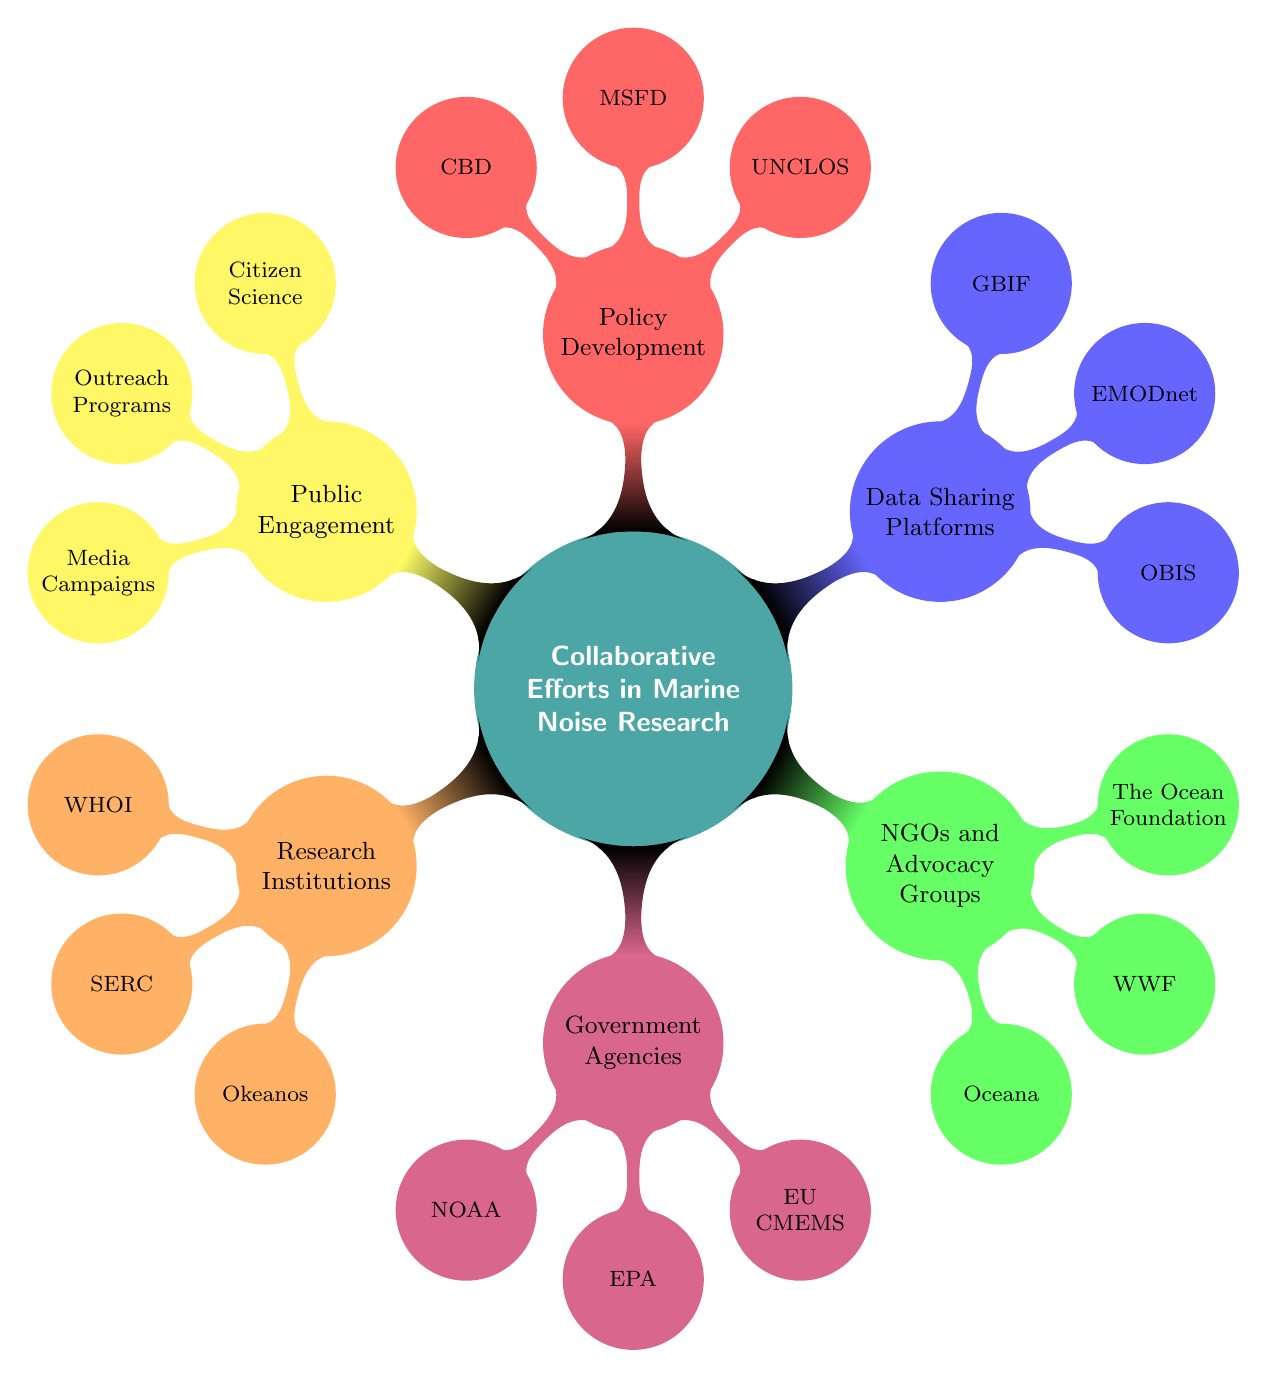What are the three main categories of collaborative efforts in marine noise research? The main categories as seen in the diagram are Research Institutions, Government Agencies, NGOs and Advocacy Groups, Data Sharing Platforms, Policy Development, and Public Engagement. There are six categories in total, but the requested three could be any selected from the list.
Answer: Research Institutions, Government Agencies, NGOs and Advocacy Groups How many research institutions are listed in the diagram? In the Research Institutions category, there are three sub-nodes: WHOI, SERC, and Okeanos. Thus, the count of research institutions is three.
Answer: 3 Which organization is represented under Government Agencies that focuses on marine environment monitoring? The European Union Copernicus Marine Environment Monitoring Service (EU CMEMS) is specifically identified as focusing on marine environment monitoring within the Government Agencies category.
Answer: EU CMEMS What is the focus of the sub-nodes under Public Engagement? The sub-nodes under Public Engagement show initiatives aimed at involving the public in marine conservation efforts. They include Citizen Science, Outreach Programs, and Media Campaigns, all of which raise awareness and participation.
Answer: Awareness and participation Which three policy development frameworks are mentioned in the diagram? The frameworks listed under Policy Development are the United Nations Convention on the Law of the Sea (UNCLOS), the Marine Strategy Framework Directive (MSFD), and the Convention on Biological Diversity (CBD). These three are aimed at regulating marine activities for biodiversity and sustainability.
Answer: UNCLOS, MSFD, CBD What type of organizations are represented as NGOs and Advocacy Groups in the diagram? The NGOs and Advocacy Groups listed include Oceana, World Wildlife Fund (WWF), and The Ocean Foundation. These organizations typically focus on marine conservation and advocating for policy changes related to marine ecosystems.
Answer: Oceana, WWF, The Ocean Foundation How does the concept of Data Sharing Platforms relate to marine noise research? Data Sharing Platforms such as OBIS, EMODnet, and GBIF allow researchers and policymakers to access and share valuable data regarding marine biodiversity and noise pollution, thereby enhancing research collaboration and informed decision-making.
Answer: Access and share valuable data What is the purpose of Citizen Science initiatives listed under Public Engagement? Citizen Science initiatives aim to involve non-professionals in scientific research, particularly in data collection and awareness about marine noise pollution, thus broadening the impact of conservation efforts.
Answer: Involve non-professionals in scientific research 